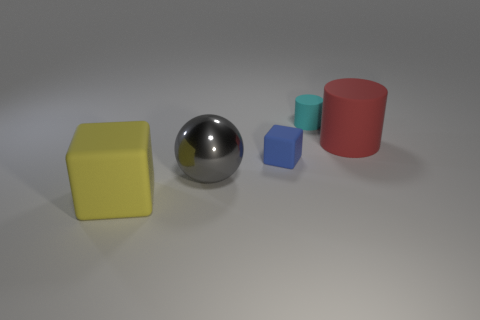How many cyan rubber things are the same shape as the blue thing?
Offer a terse response. 0. Is the big red cylinder made of the same material as the cube behind the yellow rubber thing?
Keep it short and to the point. Yes. There is a blue object that is the same material as the tiny cylinder; what is its size?
Provide a succinct answer. Small. There is a matte object that is in front of the blue matte block; what size is it?
Offer a terse response. Large. What number of metal blocks have the same size as the yellow matte block?
Ensure brevity in your answer.  0. Is there a big thing of the same color as the large rubber cube?
Your answer should be compact. No. There is a block that is the same size as the gray metal object; what is its color?
Provide a succinct answer. Yellow. Do the metallic thing and the big matte thing to the left of the red rubber cylinder have the same color?
Your answer should be compact. No. What is the color of the small cylinder?
Offer a terse response. Cyan. What is the material of the cube that is behind the yellow matte object?
Your response must be concise. Rubber. 